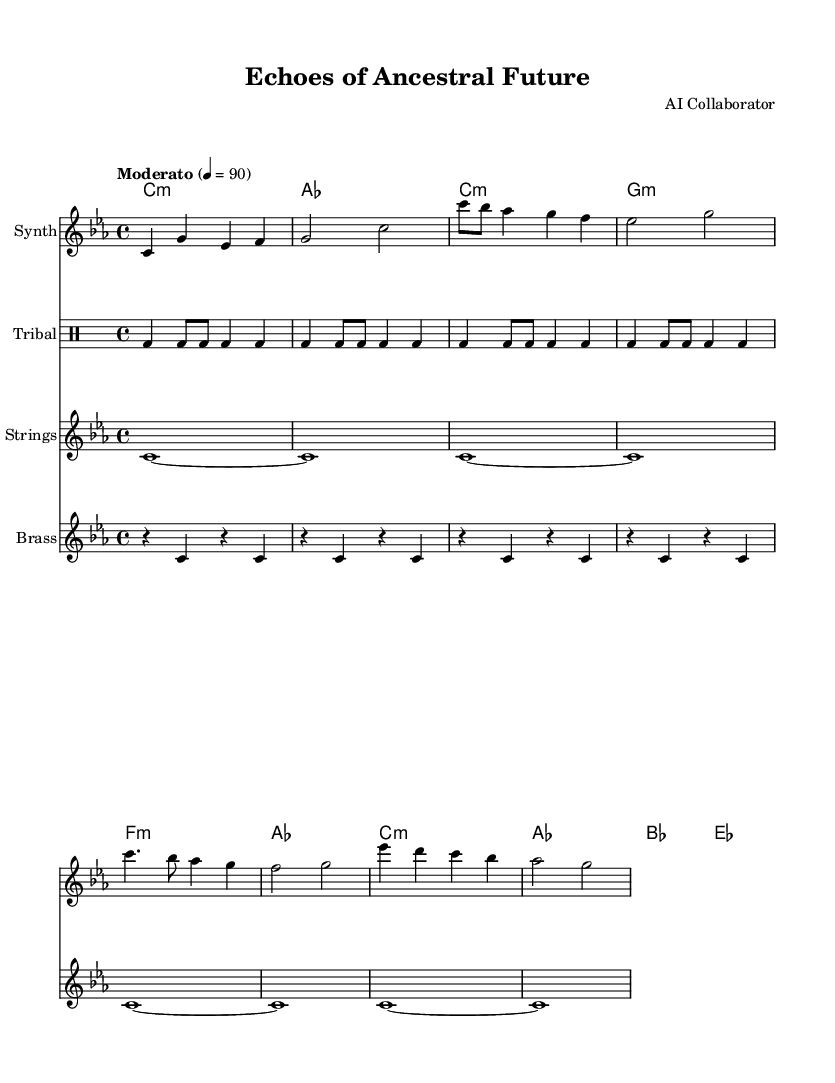What is the key signature of this music? The key signature is C minor, which has three flats (B, E, and A flat). This is determined by the note that is shown at the beginning of the staff, indicating the key.
Answer: C minor What is the time signature of this piece? The time signature is 4/4, which is indicated at the beginning of the score. This means there are four beats in each measure and a quarter note gets one beat.
Answer: 4/4 What is the tempo marking? The tempo marking is "Moderato," indicating a moderate speed for the piece. This is noted at the beginning of the score along with the metronome marking of 90 beats per minute.
Answer: Moderato How many measures are there in the synthesizer part? The synthesizer part consists of 8 measures. By counting the grouped notes separated by vertical lines in the synthesizer section, we see there are 8 groups, which represent the measures.
Answer: 8 What type of drum is used in the tribal chant section? The type of drum used in the tribal chant section is a bass drum, indicated by the "bd" abbreviation in the drum notation. Each "bd" represents a bass drum hit.
Answer: Bass drum What is the relationship between the synthesizer and the tribal chant in this composition? The synthesizer provides a melodic and harmonic backdrop complementing the rhythmic and textural elements of the tribal chant. The synthesizer's synth sounds blend with the repetitive beat of the tribal chant, creating a fusion of traditional and modern.
Answer: Complementary 